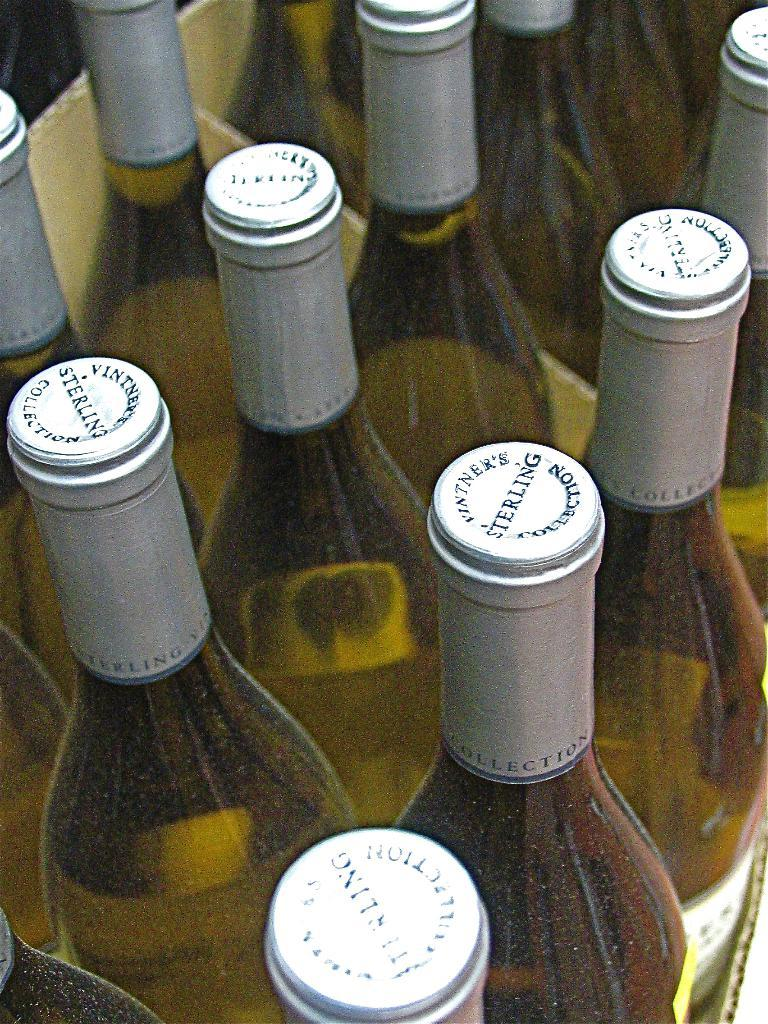<image>
Summarize the visual content of the image. Several green bottles of Sterling Vintner's Collection wine. 